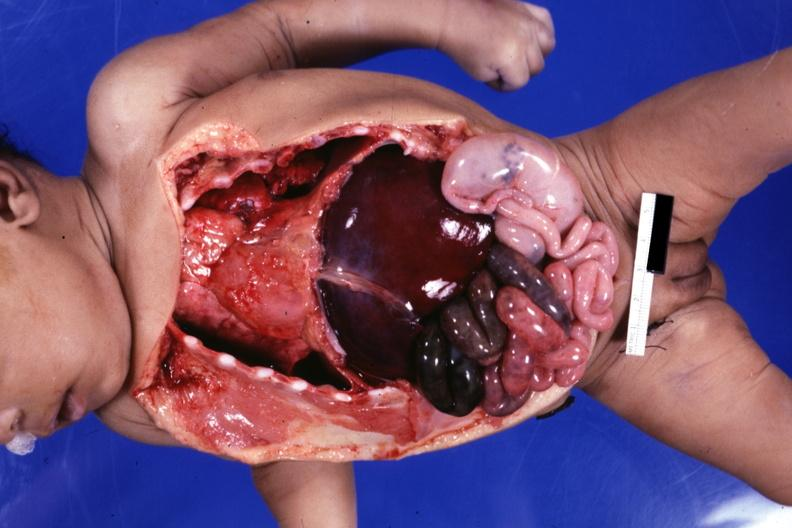what does this image show?
Answer the question using a single word or phrase. Infant body opened showing cardiac apex to right 